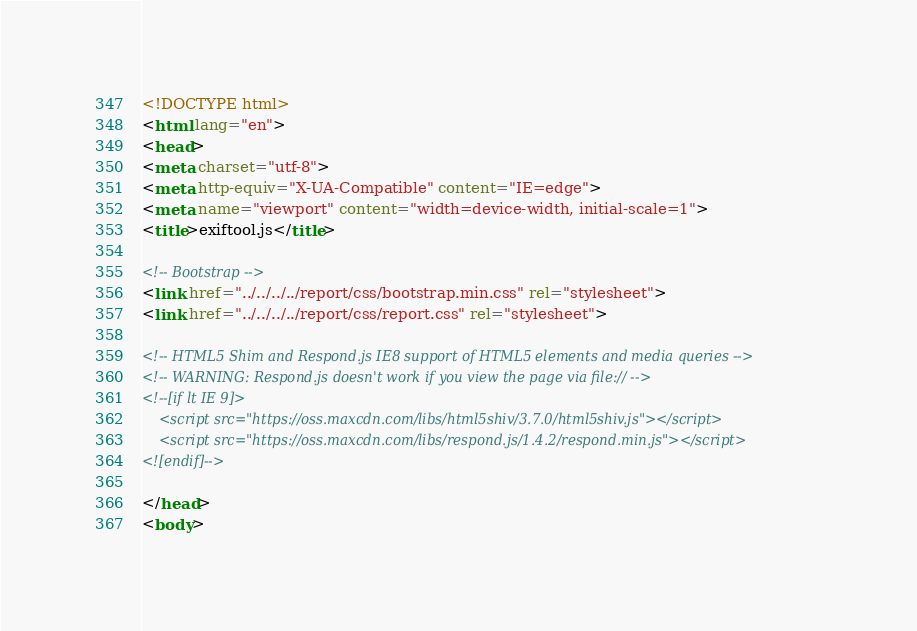<code> <loc_0><loc_0><loc_500><loc_500><_HTML_><!DOCTYPE html>
<html lang="en">
<head>
<meta charset="utf-8">
<meta http-equiv="X-UA-Compatible" content="IE=edge">
<meta name="viewport" content="width=device-width, initial-scale=1">
<title>exiftool.js</title>

<!-- Bootstrap -->
<link href="../../../../report/css/bootstrap.min.css" rel="stylesheet">
<link href="../../../../report/css/report.css" rel="stylesheet">

<!-- HTML5 Shim and Respond.js IE8 support of HTML5 elements and media queries -->
<!-- WARNING: Respond.js doesn't work if you view the page via file:// -->
<!--[if lt IE 9]>
    <script src="https://oss.maxcdn.com/libs/html5shiv/3.7.0/html5shiv.js"></script>
    <script src="https://oss.maxcdn.com/libs/respond.js/1.4.2/respond.min.js"></script>
<![endif]-->

</head>
<body>
</code> 